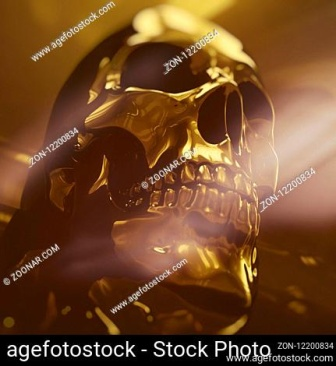Imagine a story where this golden skull plays a central role. In a distant land, long-hidden beneath the sands of an ancient desert, an archaeologist uncovers a golden skull during an excavation. The skull, shimmering with an eerie light, is said to be the key to a treasure beyond imagination. However, as the archaeologist tries to decipher its mysteries, they learn that the skull is cursed. Each owner of the skull is bestowed with immense wealth, but at the cost of immense peril. The archaeologist must now navigate a maze of traps, ancient guardians, and shadowy figures eager to seize the skull, all while unraveling the true secret it holds—an enchantment that could alter the fate of humanity itself.  Describe the details and atmosphere of the cavern where the golden skull was found. The cavern where the golden skull was found is vast and echoing, a labyrinthine expanse buried deep within the heart of an ancient temple. The air is thick with the scent of earth and time, and the ground is uneven, strewn with crumbled stones and half-buried artifacts. Stalactites hang menacingly from the ceiling, glistening with moisture that reflects the dim torchlight. The walls are adorned with faded murals, telling the story of an ancient civilization’s rise and fall. In the center of this chamber, on a pedestal intricately carved with symbols and figures of deities, rests the golden skull, bathed in a shaft of light from a crevice high above. The atmosphere is one of awe and foreboding, as if the very air hums with the power and secrets of the ages.  If the skull could speak, what wisdom would it impart? If the golden skull could speak, it might share the wisdom of countless ages: "I am both a relic and a mirror of all who gaze upon me. From the sands of time, I have seen empires rise and fall, and the folly of mankind’s greed. In my silence, I hold the memory of lives long past and the echoes of ambitions turned to dust. Treasure not the gold that glitters, but the moments of truth and love that enrich the soul. In the quiet between breaths, find the eternity that binds us all."  Envision a futuristic scenario where the golden skull is discovered by archaeologists hundreds of years from now. How does society react? In a future where humanity has expanded into the cosmos, the discovery of the golden skull sparks a blend of scientific curiosity and cultural reflection. Found on a terraformed planet rich in ancient ruins, the skull quickly becomes a centerpiece of global intrigue. Advanced technologies allow archaeologists to uncover its origins and the civilization that crafted it. Scientists study its material composition, marveling at the archaic techniques that have preserved its lustrous finish. Meanwhile, society reacts with a sense of reverence, seeing the golden skull as a link to their collective past, a reminder of early human endeavors and the perennial quest for meaning. Virtual reality exhibits and immersive holographic displays are created, allowing millions to experience the skull within its original context. The skull becomes a symbol of continuity and an artifact that bridges the vast expanse between ancient and space-age civilizations.  Who were the original owners of the golden skull and what was its purpose? The original owners of the golden skull were the members of an ancient, now-extinct civilization known as the Luminas. Renowned for their advanced knowledge in metallurgy and ritualistic artistry, the Luminas held the skull as a sacred relic within their grand temple. Its purpose was both spiritual and ceremonial. Believed to house the essence of their greatest leader, the skull was used in rituals to seek guidance and blessings during times of turmoil and celebration. It was also a symbol of immense power and divine favor, passed down through generations to the high priests who acted as the intermediaries between the gods and the people. 